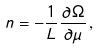Convert formula to latex. <formula><loc_0><loc_0><loc_500><loc_500>n = - \frac { 1 } { L } \frac { \partial \Omega } { \partial \mu } \, ,</formula> 